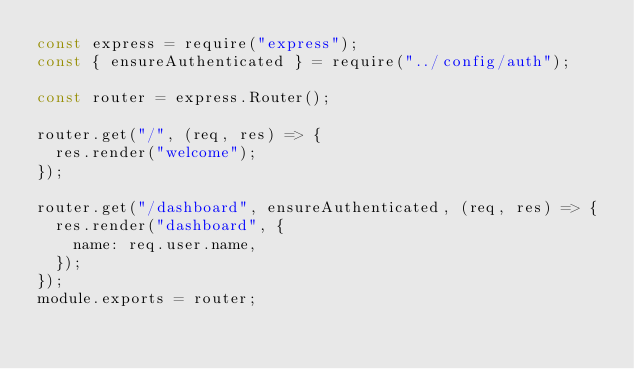Convert code to text. <code><loc_0><loc_0><loc_500><loc_500><_JavaScript_>const express = require("express");
const { ensureAuthenticated } = require("../config/auth");

const router = express.Router();

router.get("/", (req, res) => {
  res.render("welcome");
});

router.get("/dashboard", ensureAuthenticated, (req, res) => {
  res.render("dashboard", {
    name: req.user.name,
  });
});
module.exports = router;
</code> 